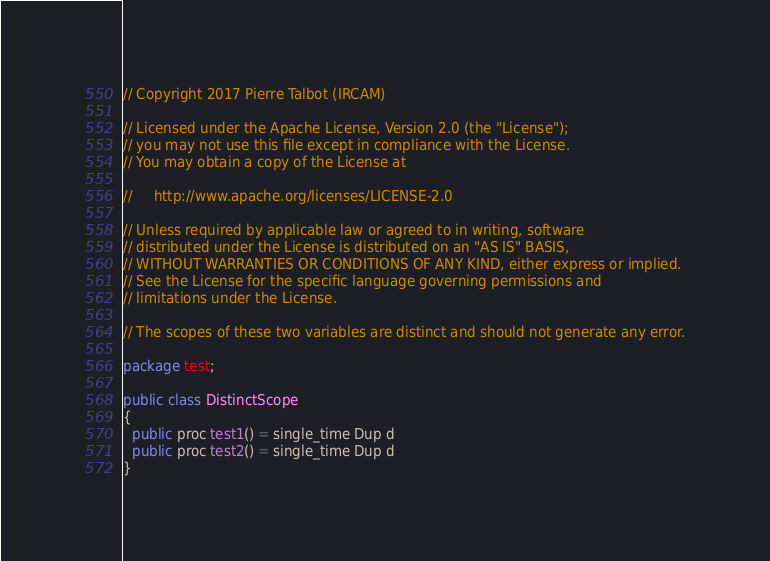<code> <loc_0><loc_0><loc_500><loc_500><_Java_>// Copyright 2017 Pierre Talbot (IRCAM)

// Licensed under the Apache License, Version 2.0 (the "License");
// you may not use this file except in compliance with the License.
// You may obtain a copy of the License at

//     http://www.apache.org/licenses/LICENSE-2.0

// Unless required by applicable law or agreed to in writing, software
// distributed under the License is distributed on an "AS IS" BASIS,
// WITHOUT WARRANTIES OR CONDITIONS OF ANY KIND, either express or implied.
// See the License for the specific language governing permissions and
// limitations under the License.

// The scopes of these two variables are distinct and should not generate any error.

package test;

public class DistinctScope
{
  public proc test1() = single_time Dup d
  public proc test2() = single_time Dup d
}
</code> 